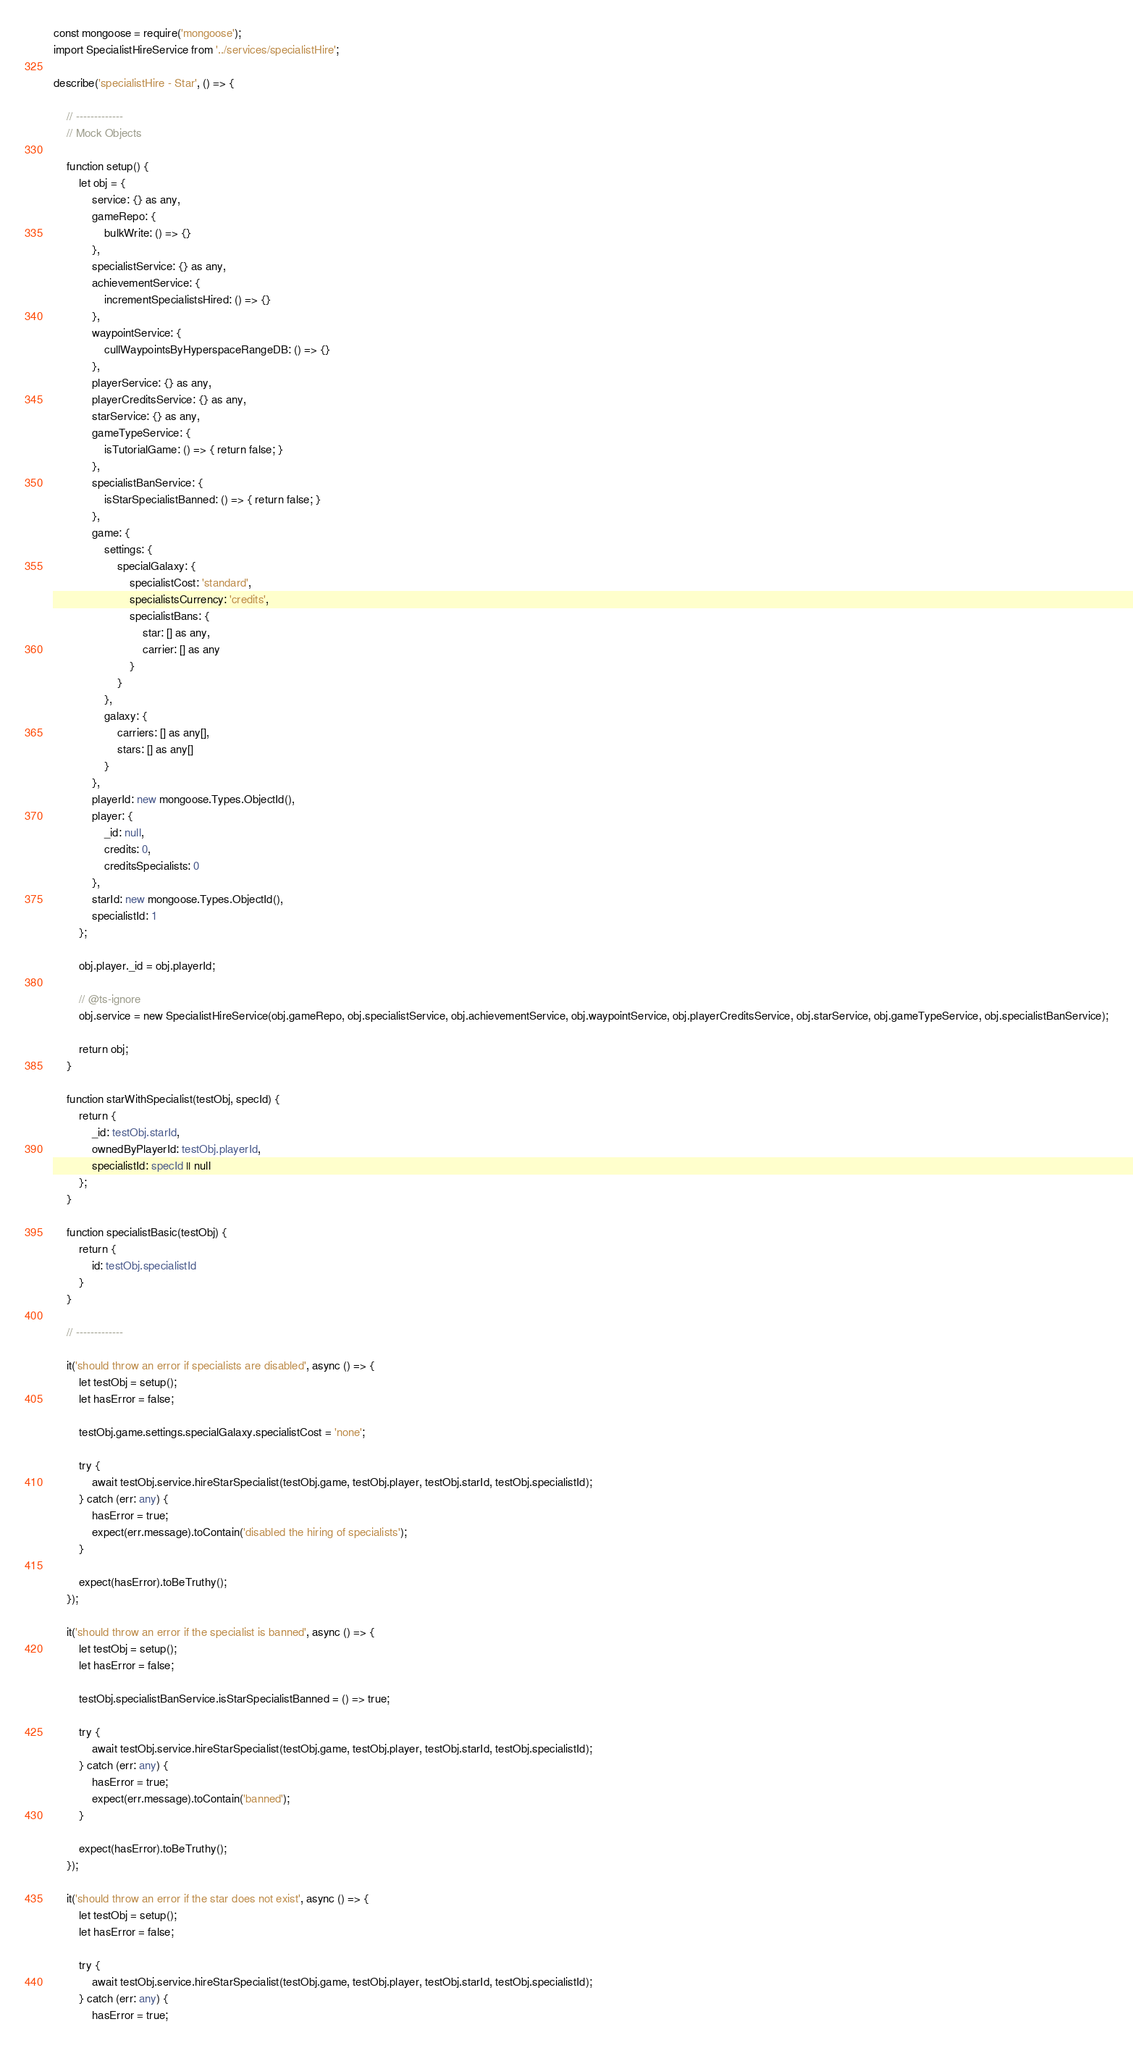<code> <loc_0><loc_0><loc_500><loc_500><_TypeScript_>const mongoose = require('mongoose');
import SpecialistHireService from '../services/specialistHire';

describe('specialistHire - Star', () => {

    // -------------
    // Mock Objects

    function setup() {
        let obj = {
            service: {} as any,
            gameRepo: {
                bulkWrite: () => {}
            },
            specialistService: {} as any,
            achievementService: {
                incrementSpecialistsHired: () => {}
            },
            waypointService: {
                cullWaypointsByHyperspaceRangeDB: () => {}
            },
            playerService: {} as any,
            playerCreditsService: {} as any,
            starService: {} as any,
            gameTypeService: {
                isTutorialGame: () => { return false; }
            },
            specialistBanService: {
                isStarSpecialistBanned: () => { return false; }
            },
            game: { 
                settings: {
                    specialGalaxy: {
                        specialistCost: 'standard',
                        specialistsCurrency: 'credits',
                        specialistBans: {
                            star: [] as any,
                            carrier: [] as any
                        }
                    }
                },
                galaxy: {
                    carriers: [] as any[],
                    stars: [] as any[]
                }
            },
            playerId: new mongoose.Types.ObjectId(),
            player: {
                _id: null,
                credits: 0,
                creditsSpecialists: 0
            },
            starId: new mongoose.Types.ObjectId(),
            specialistId: 1
        };

        obj.player._id = obj.playerId;

        // @ts-ignore
        obj.service = new SpecialistHireService(obj.gameRepo, obj.specialistService, obj.achievementService, obj.waypointService, obj.playerCreditsService, obj.starService, obj.gameTypeService, obj.specialistBanService);

        return obj;
    }

    function starWithSpecialist(testObj, specId) {
        return {
            _id: testObj.starId,
            ownedByPlayerId: testObj.playerId,
            specialistId: specId || null
        };
    }

    function specialistBasic(testObj) {
        return {
            id: testObj.specialistId
        }
    }

    // -------------

    it('should throw an error if specialists are disabled', async () => {
        let testObj = setup();
        let hasError = false;

        testObj.game.settings.specialGalaxy.specialistCost = 'none';

        try {
            await testObj.service.hireStarSpecialist(testObj.game, testObj.player, testObj.starId, testObj.specialistId);
        } catch (err: any) {
            hasError = true;
            expect(err.message).toContain('disabled the hiring of specialists');
        }
        
        expect(hasError).toBeTruthy();
    });

    it('should throw an error if the specialist is banned', async () => {
        let testObj = setup();
        let hasError = false;

        testObj.specialistBanService.isStarSpecialistBanned = () => true;

        try {
            await testObj.service.hireStarSpecialist(testObj.game, testObj.player, testObj.starId, testObj.specialistId);
        } catch (err: any) {
            hasError = true;
            expect(err.message).toContain('banned');
        }
        
        expect(hasError).toBeTruthy();
    });

    it('should throw an error if the star does not exist', async () => {
        let testObj = setup();
        let hasError = false;

        try {
            await testObj.service.hireStarSpecialist(testObj.game, testObj.player, testObj.starId, testObj.specialistId);
        } catch (err: any) {
            hasError = true;</code> 